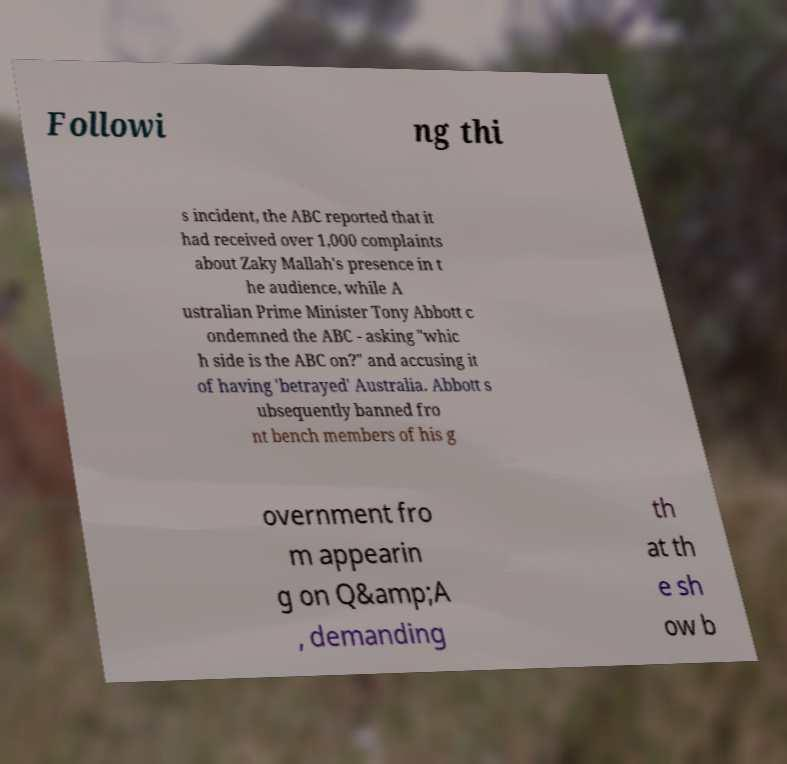Can you accurately transcribe the text from the provided image for me? Followi ng thi s incident, the ABC reported that it had received over 1,000 complaints about Zaky Mallah's presence in t he audience, while A ustralian Prime Minister Tony Abbott c ondemned the ABC - asking "whic h side is the ABC on?" and accusing it of having 'betrayed' Australia. Abbott s ubsequently banned fro nt bench members of his g overnment fro m appearin g on Q&amp;A , demanding th at th e sh ow b 